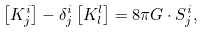<formula> <loc_0><loc_0><loc_500><loc_500>\left [ K ^ { i } _ { j } \right ] - \delta ^ { i } _ { j } \left [ K ^ { l } _ { l } \right ] = 8 \pi G \cdot S ^ { i } _ { j } ,</formula> 